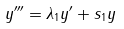Convert formula to latex. <formula><loc_0><loc_0><loc_500><loc_500>y ^ { \prime \prime \prime } = \lambda _ { 1 } y ^ { \prime } + s _ { 1 } y</formula> 